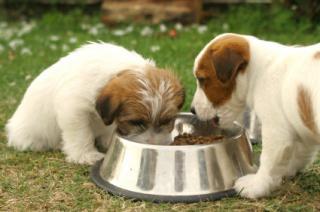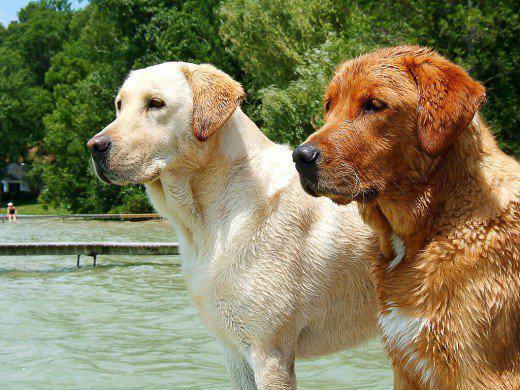The first image is the image on the left, the second image is the image on the right. Given the left and right images, does the statement "No more than 3 puppies are eating food from a bowl." hold true? Answer yes or no. Yes. The first image is the image on the left, the second image is the image on the right. Evaluate the accuracy of this statement regarding the images: "There are no more than four dogs.". Is it true? Answer yes or no. Yes. 